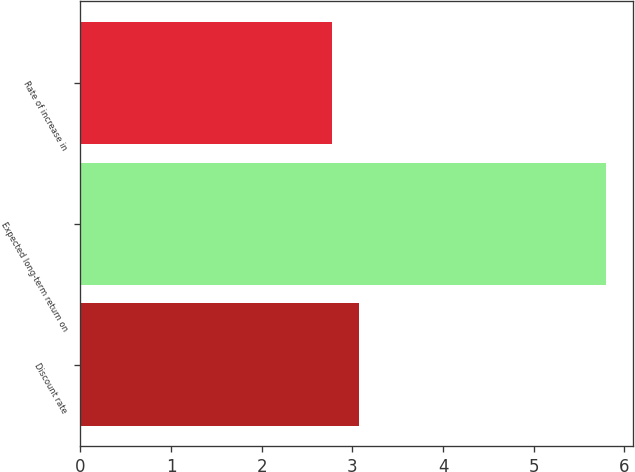Convert chart. <chart><loc_0><loc_0><loc_500><loc_500><bar_chart><fcel>Discount rate<fcel>Expected long-term return on<fcel>Rate of increase in<nl><fcel>3.07<fcel>5.8<fcel>2.77<nl></chart> 